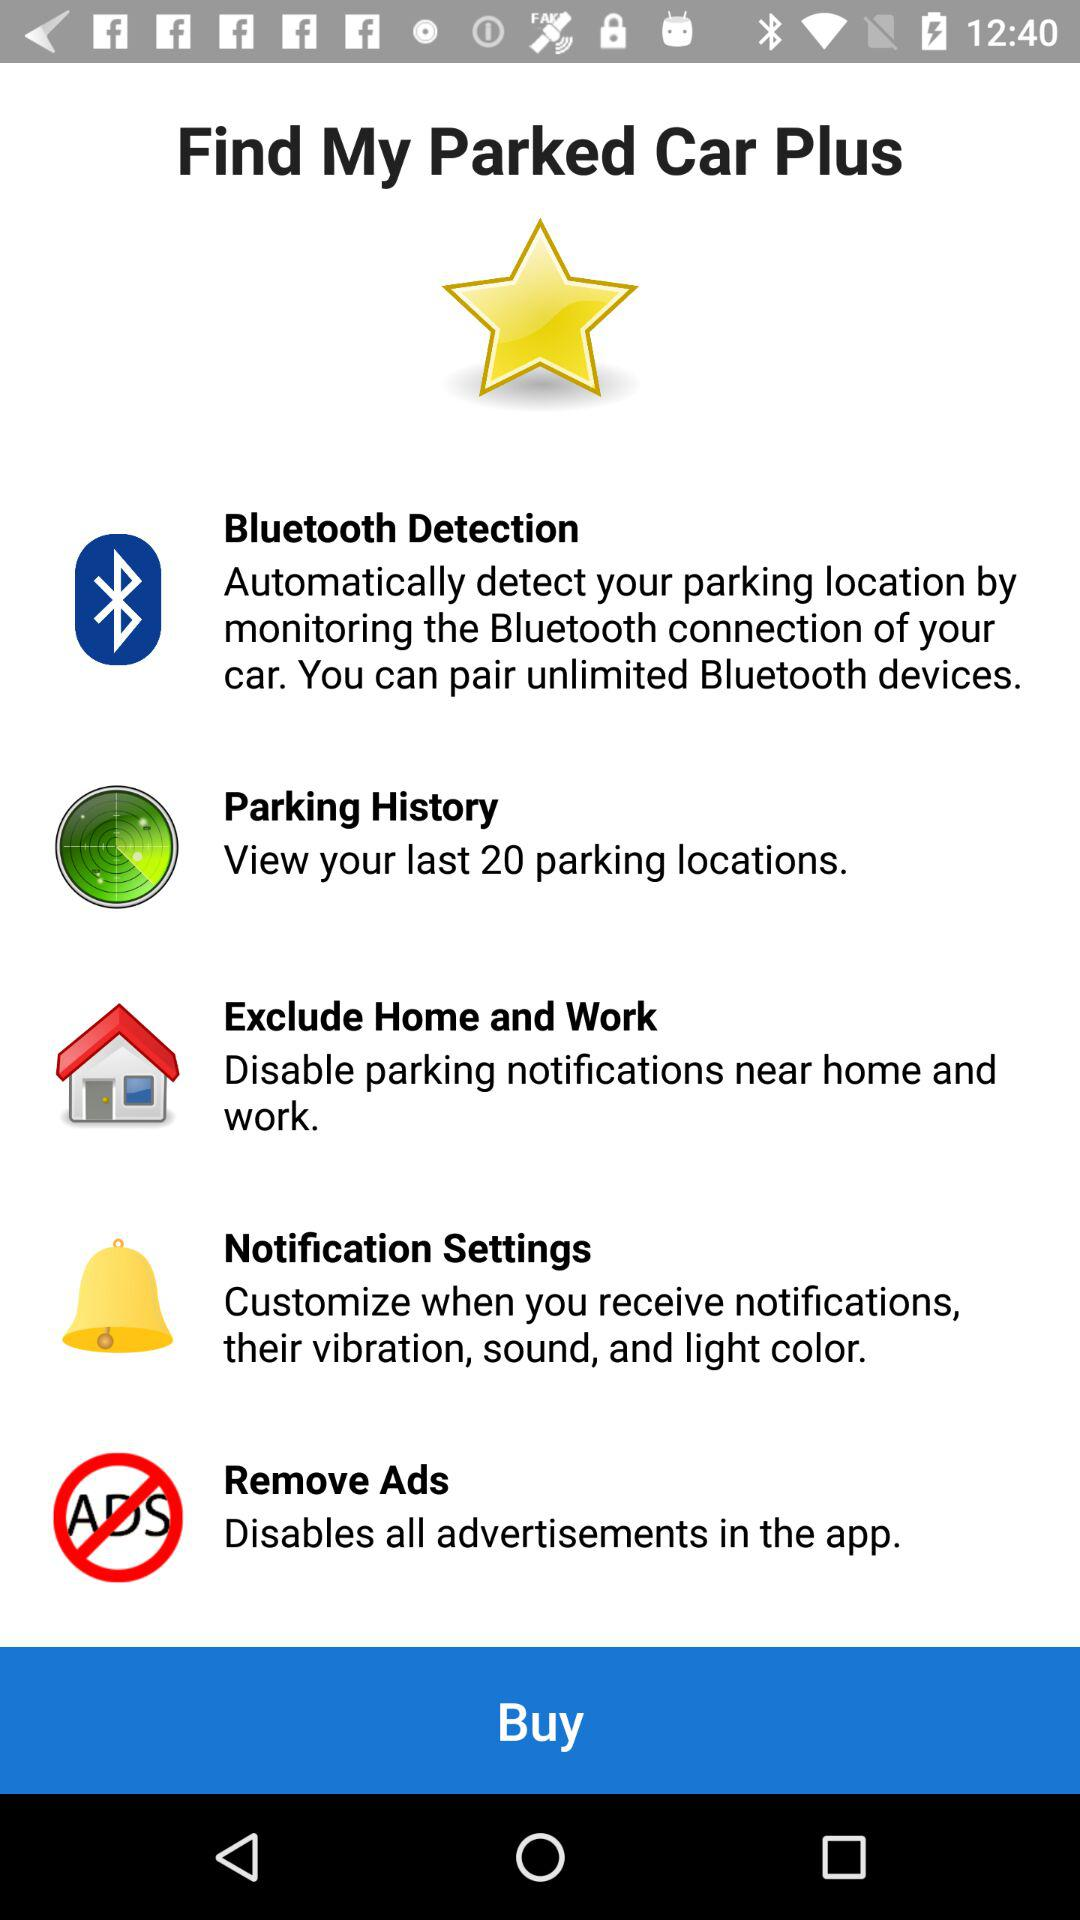Which locations do the parking notifications exclude? The parking notifications exclude home and work. 